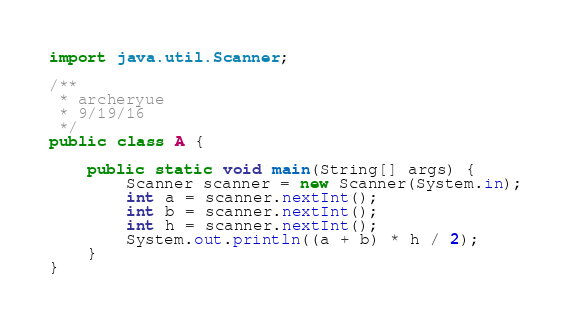<code> <loc_0><loc_0><loc_500><loc_500><_Java_>import java.util.Scanner;

/**
 * archeryue
 * 9/19/16
 */
public class A {

    public static void main(String[] args) {
        Scanner scanner = new Scanner(System.in);
        int a = scanner.nextInt();
        int b = scanner.nextInt();
        int h = scanner.nextInt();
        System.out.println((a + b) * h / 2);
    }
}</code> 